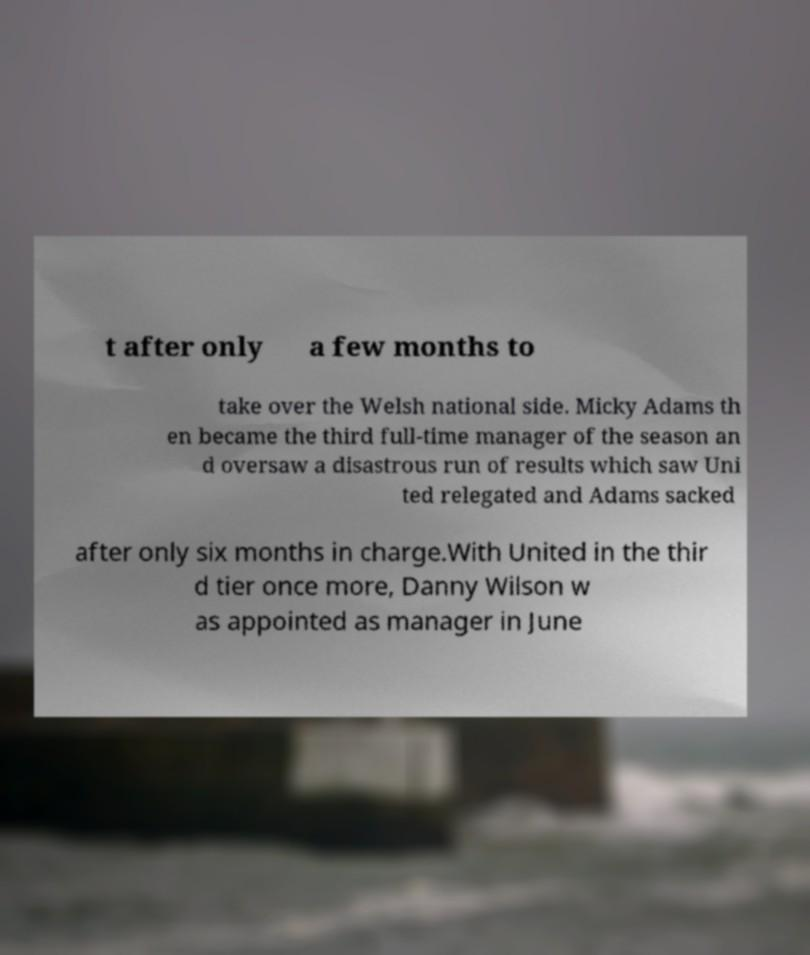Please read and relay the text visible in this image. What does it say? t after only a few months to take over the Welsh national side. Micky Adams th en became the third full-time manager of the season an d oversaw a disastrous run of results which saw Uni ted relegated and Adams sacked after only six months in charge.With United in the thir d tier once more, Danny Wilson w as appointed as manager in June 